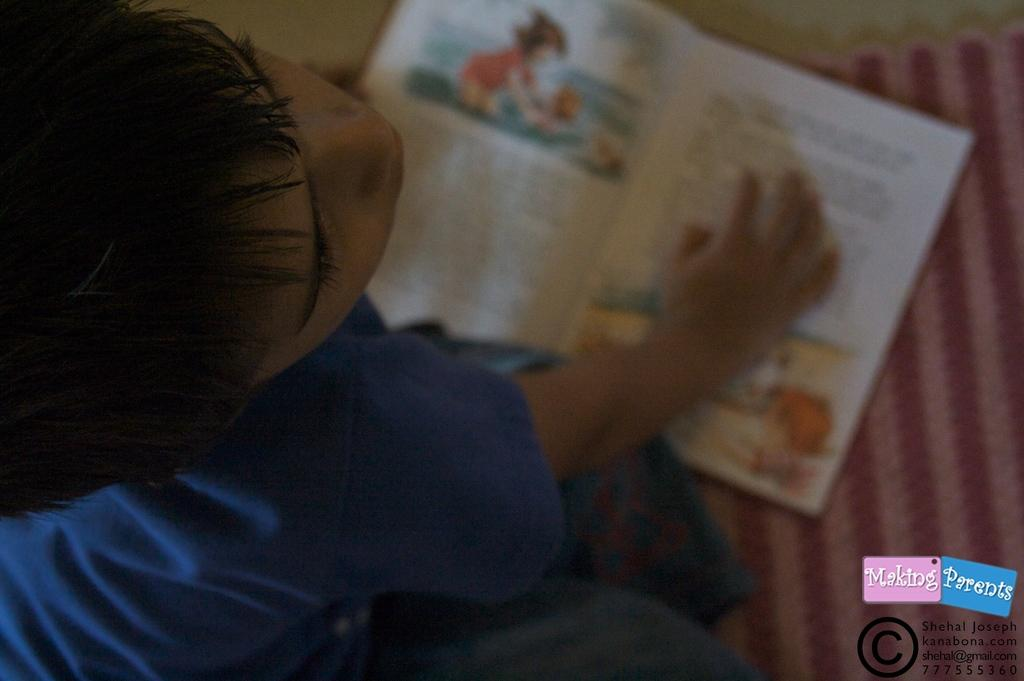What is the main subject of the image? The main subject of the image is a kid. What object is visible in the image besides the kid? There is a book in the image. Where is the book located in relation to the kid? The book is on a mat, and the mat is in front of the kid. What is the condition of the fly that is smashing the book in the image? There is no fly present in the image, and the book is not being smashed. 